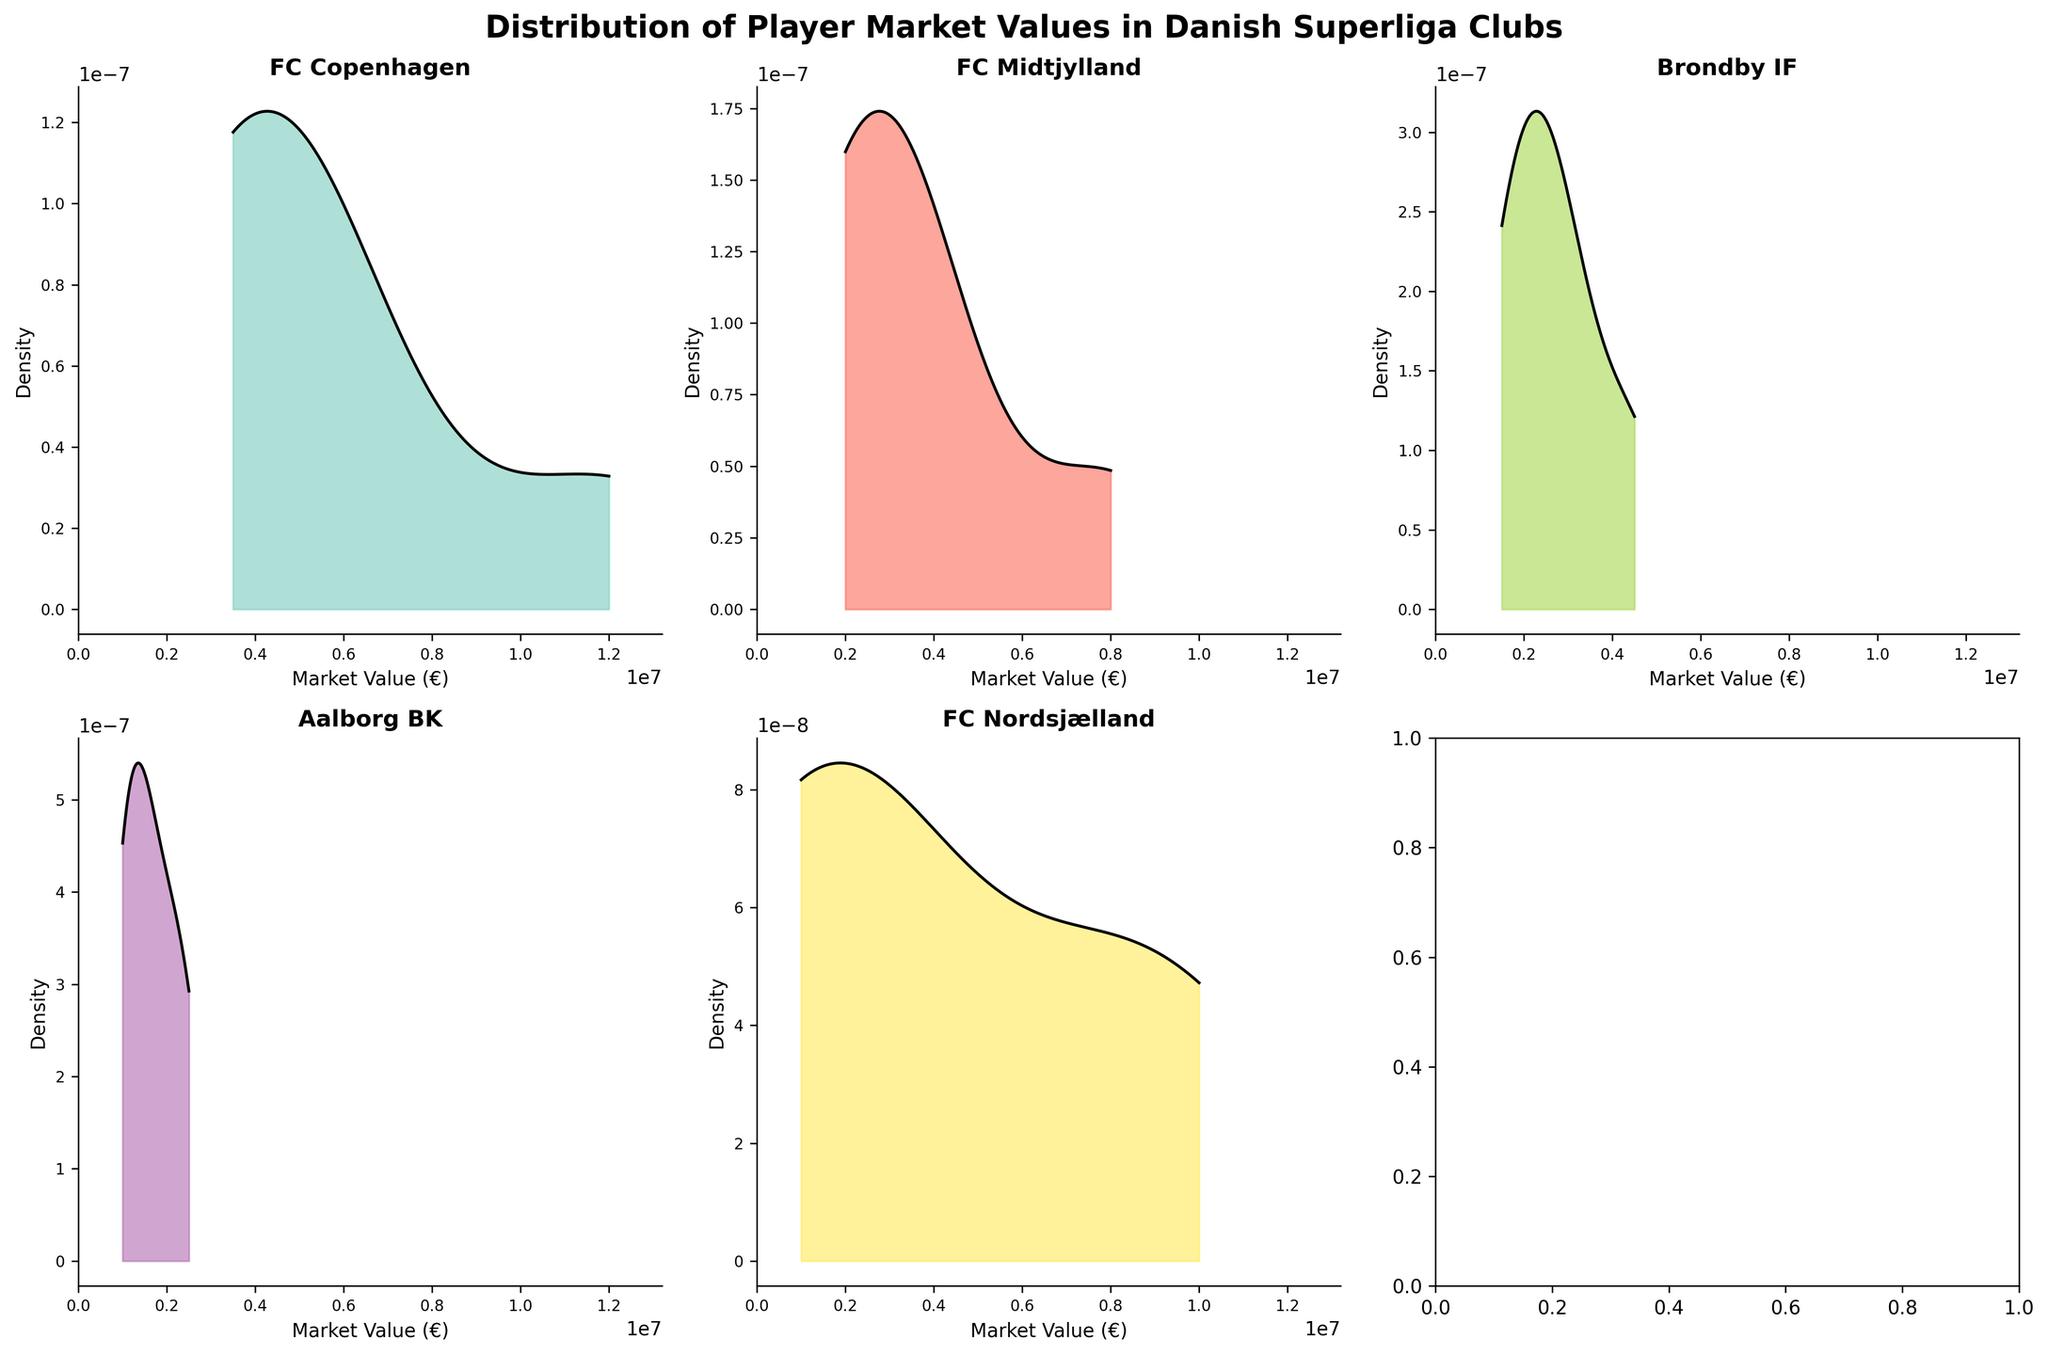What's the title of the figure? The title of the figure is displayed at the top of the plot, reading "Distribution of Player Market Values in Danish Superliga Clubs".
Answer: Distribution of Player Market Values in Danish Superliga Clubs How many clubs are represented in the subplots? By counting the individual subplots or by noting the number of unique titles within the subplots, we can determine there are five clubs represented.
Answer: Five Which club has the highest peak density in their plot? By observing the density peaks visually, the club with the highest peak can be identified. FC Copenhagen has the highest peak density among the clubs.
Answer: FC Copenhagen Which club has the broadest range of market values? By looking at the x-axis range each club's density plot covers, we can identify the club with the broadest range. FC Nordsjælland has the widest range, spanning from approximately €1 million to €10 million.
Answer: FC Nordsjælland Are there any clubs with a bimodal distribution of player market values? Bimodal distribution means the plot has two noticeable peaks. FC Midtjylland shows a bimodal distribution with peaks around €3.5 million and €8 million.
Answer: FC Midtjylland Which two clubs have the most dissimilar densities? By comparing the shapes and spread of the density plots visually, the two most dissimilar clubs can be identified. FC Copenhagen and Aalborg BK appear to have significantly different density distributions, with FC Copenhagen having a sharp high peak while Aalborg BK has a more spread out and lower peak.
Answer: FC Copenhagen and Aalborg BK What is the approximate market value range of the densest part of FC Copenhagen's distribution? By looking at the x-axis range corresponding to the highest peak density in the FC Copenhagen subplot, we can approximate it covers from about €3.5 million to €5 million.
Answer: €3.5 million to €5 million Which club's players have the highest median market value? The median can be approximated from the density peak. FC Nordsjælland's peak is skewed towards higher values compared to other clubs, indicating a higher median market value.
Answer: FC Nordsjælland What is the shape of the individual density plot for Brøndby IF? Observing Brøndby IF's subplot, the density plot shape can be described. It is a unimodal distribution with a peak around €2.5 million.
Answer: Unimodal around €2.5 million 